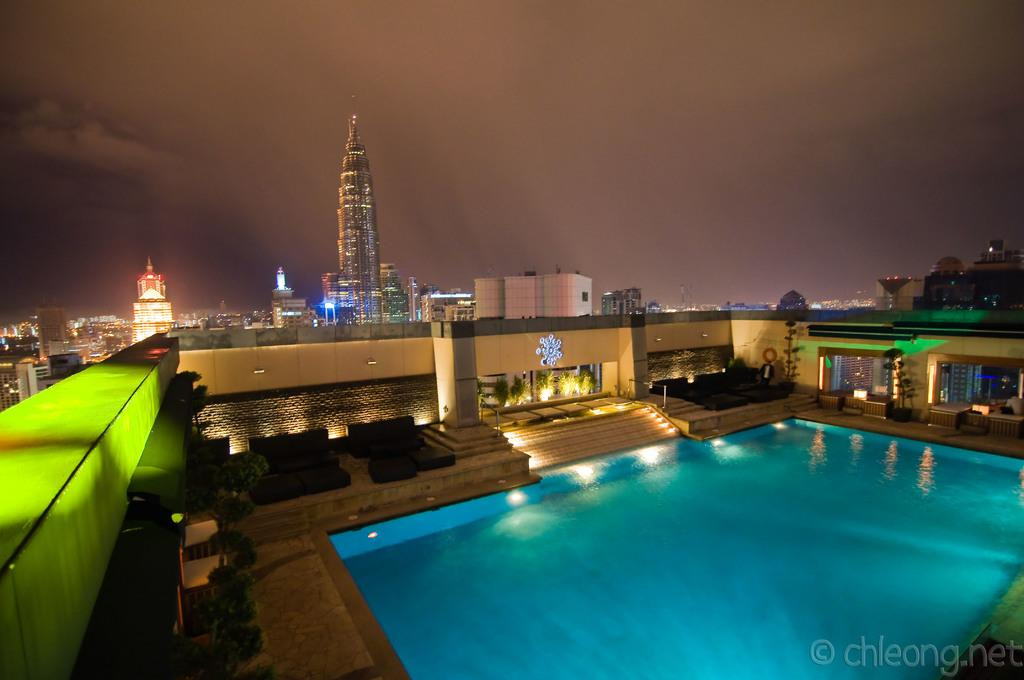What type of structures can be seen in the image? There are buildings in the image. What type of vegetation is present in the image? There are plants in the image. What architectural feature is visible in the image? There are stairs in the image. What type of lighting is present in the image? There are lights in the image. What part of the natural environment is visible in the image? The sky is visible in the image. What type of recreational feature is present in the image? There is a pool in the image. Can you tell me how many umbrellas are open above the pool in the image? There are no umbrellas present in the image, and therefore no such objects can be observed. What type of appliance is being used to serve drinks in the image? There is no appliance present in the image for serving drinks. 